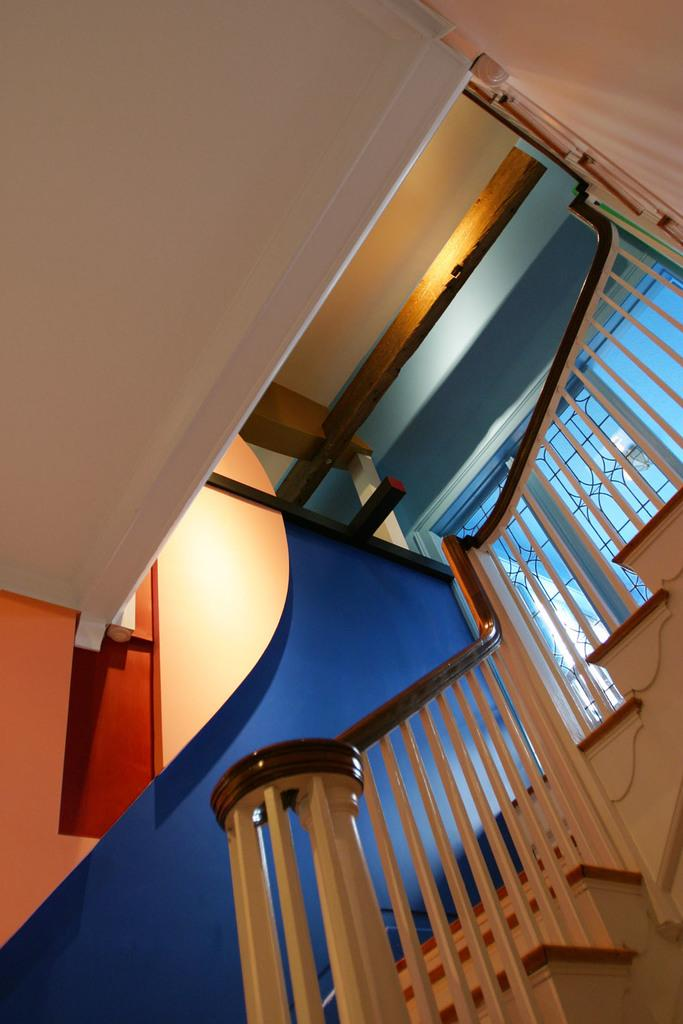What type of structure can be seen in the image? There are stairs in the image. What else is visible in the image? There is a wall and a ceiling in the image. Can you describe the setting of the image? The image is an inside view of a house. What type of iron is being used to control the temperature in the image? There is no iron or temperature control device present in the image. 